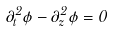<formula> <loc_0><loc_0><loc_500><loc_500>\partial _ { t } ^ { 2 } \phi - \partial _ { z } ^ { 2 } \phi = 0</formula> 